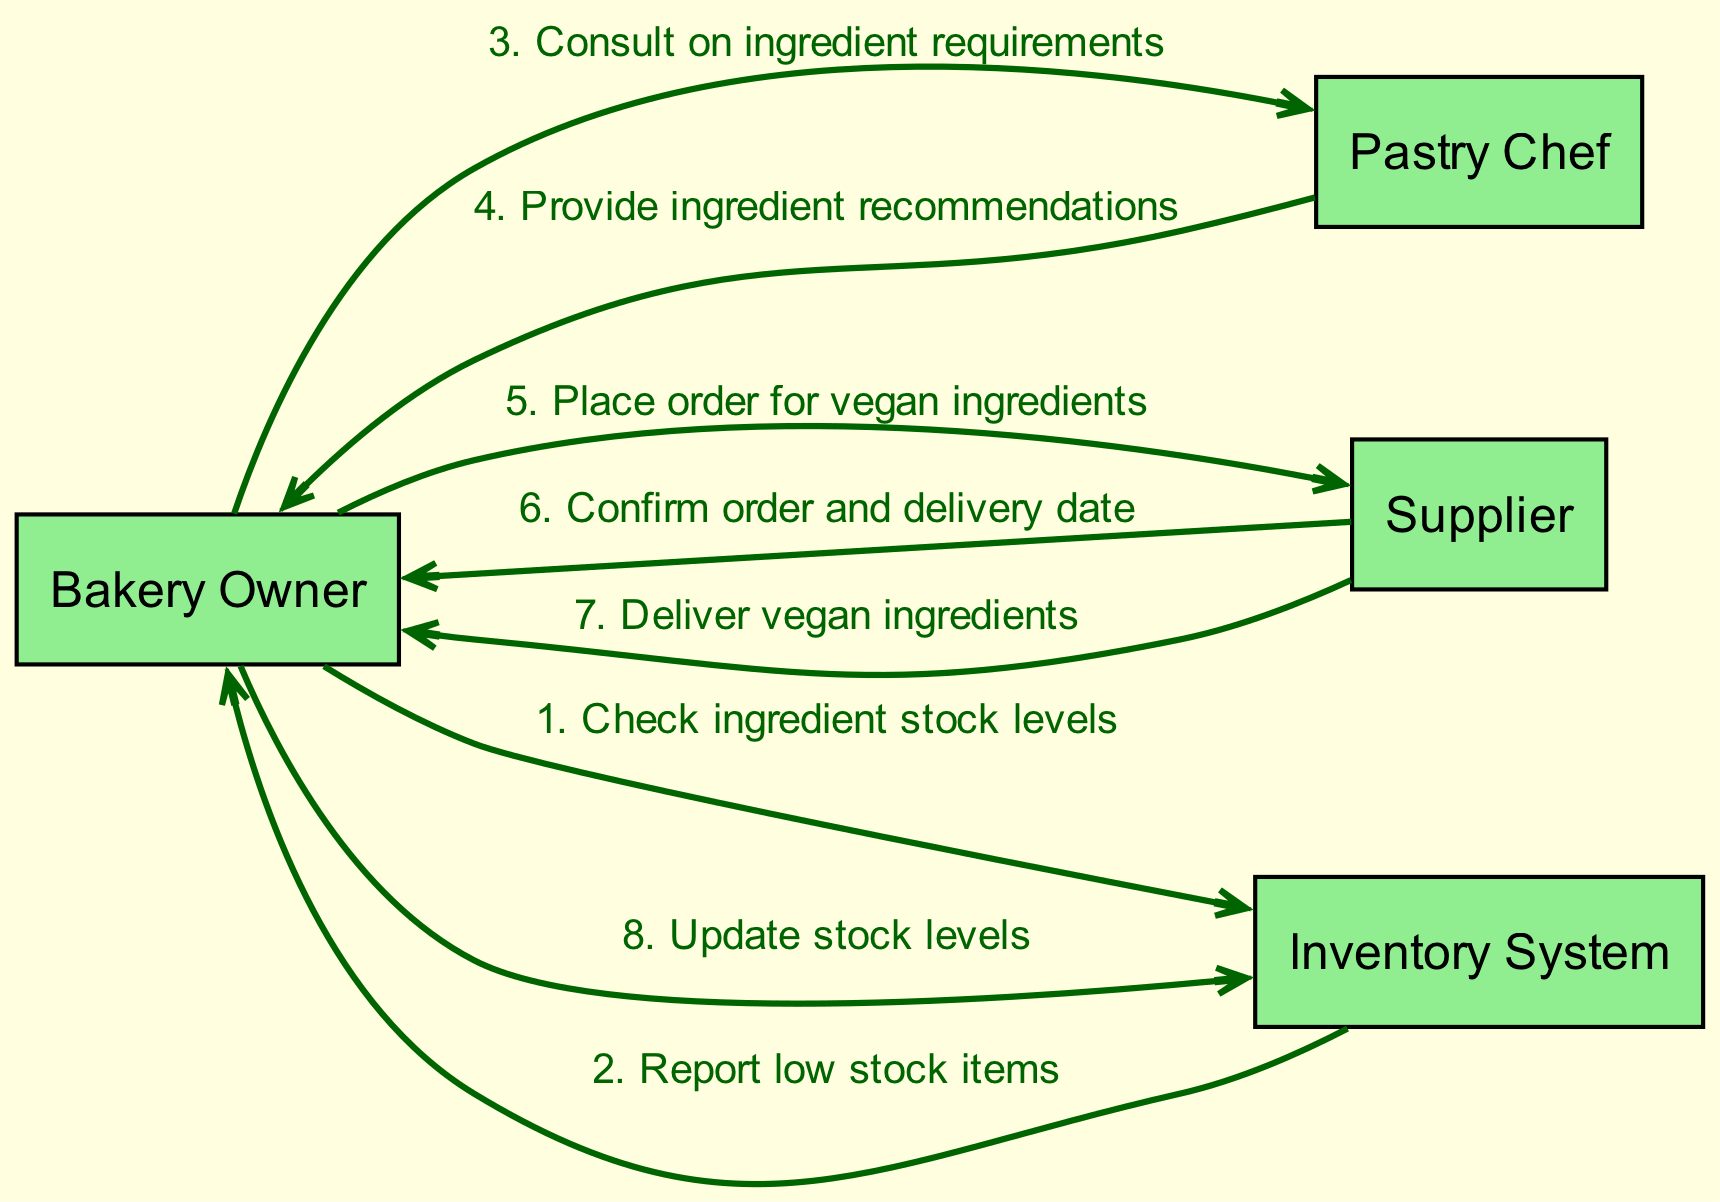What are the actors involved in the process? The actors listed in the diagram are Bakery Owner, Pastry Chef, Supplier, and Inventory System. This can be seen as these entities are represented at the beginning of the flow in the diagram.
Answer: Bakery Owner, Pastry Chef, Supplier, Inventory System How many actions take place in the diagram? The diagram includes a total of eight actions, each connecting two actors with a message. This count can be verified by counting the edges in the diagram.
Answer: Eight What is the first action taken by the Bakery Owner? The first action mentioned in the diagram involves the Bakery Owner checking ingredient stock levels with the Inventory System. This action is the initiating step in the sequence.
Answer: Check ingredient stock levels Which actor provides ingredient recommendations? The Pastry Chef is the actor who provides ingredient recommendations to the Bakery Owner based on the consultation regarding ingredient requirements. This can be identified by following the flow from the Pastry Chef to the Bakery Owner.
Answer: Pastry Chef What happens after the Bakery Owner places an order? After placing an order for vegan ingredients, the Supplier confirms the order and delivery date back to the Bakery Owner. This step is shown as a direct consequence of the ordering action in the sequence.
Answer: Confirm order and delivery date How many messages are sent from the Supplier to the Bakery Owner? The Supplier sends two messages to the Bakery Owner: one confirming the order and delivery date and another delivering the vegan ingredients. This can be counted by looking at the edges originating from the Supplier.
Answer: Two Which action follows the delivery of vegan ingredients? The action that follows the delivery of vegan ingredients is the Bakery Owner updating the stock levels in the Inventory System. This demonstrates the final step in the sequence leading to inventory adjustments.
Answer: Update stock levels What is the relationship between the Inventory System and the Bakery Owner? The Bakery Owner interacts with the Inventory System primarily to check ingredient stock levels and update stock levels based on deliveries. This interaction highlights the inventory management process.
Answer: Interaction for stock levels 